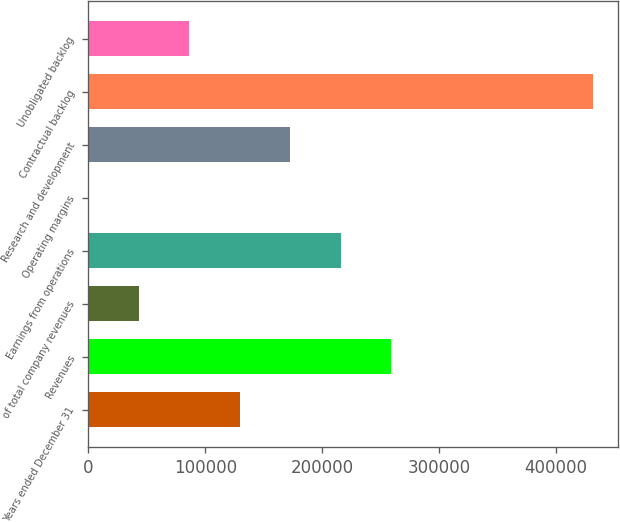Convert chart to OTSL. <chart><loc_0><loc_0><loc_500><loc_500><bar_chart><fcel>Years ended December 31<fcel>Revenues<fcel>of total company revenues<fcel>Earnings from operations<fcel>Operating margins<fcel>Research and development<fcel>Contractual backlog<fcel>Unobligated backlog<nl><fcel>129428<fcel>258848<fcel>43147.8<fcel>215708<fcel>7.8<fcel>172568<fcel>431408<fcel>86287.8<nl></chart> 